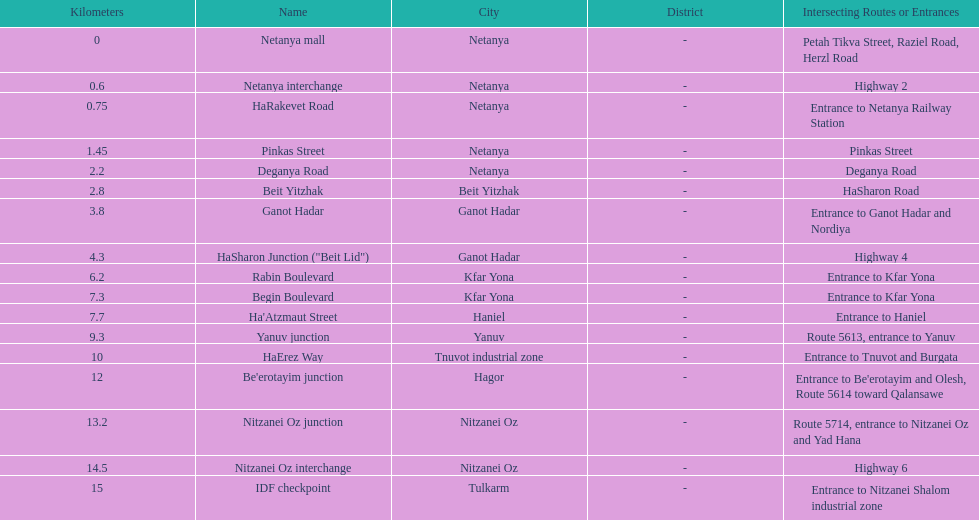How many portions are lo?cated in netanya 5. 